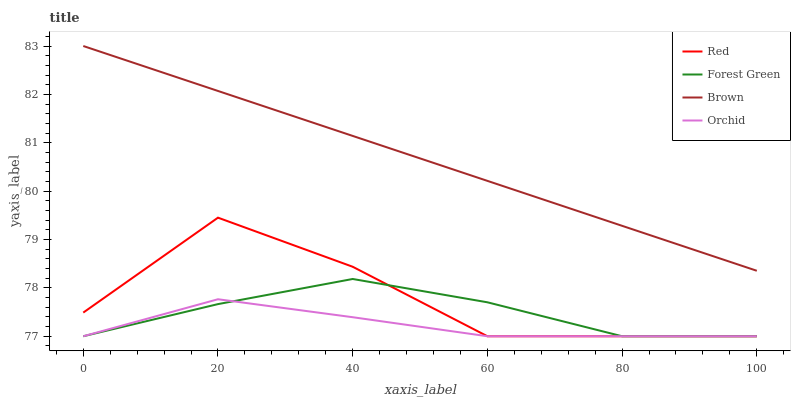Does Orchid have the minimum area under the curve?
Answer yes or no. Yes. Does Brown have the maximum area under the curve?
Answer yes or no. Yes. Does Forest Green have the minimum area under the curve?
Answer yes or no. No. Does Forest Green have the maximum area under the curve?
Answer yes or no. No. Is Brown the smoothest?
Answer yes or no. Yes. Is Red the roughest?
Answer yes or no. Yes. Is Forest Green the smoothest?
Answer yes or no. No. Is Forest Green the roughest?
Answer yes or no. No. Does Forest Green have the lowest value?
Answer yes or no. Yes. Does Brown have the highest value?
Answer yes or no. Yes. Does Forest Green have the highest value?
Answer yes or no. No. Is Forest Green less than Brown?
Answer yes or no. Yes. Is Brown greater than Orchid?
Answer yes or no. Yes. Does Forest Green intersect Red?
Answer yes or no. Yes. Is Forest Green less than Red?
Answer yes or no. No. Is Forest Green greater than Red?
Answer yes or no. No. Does Forest Green intersect Brown?
Answer yes or no. No. 